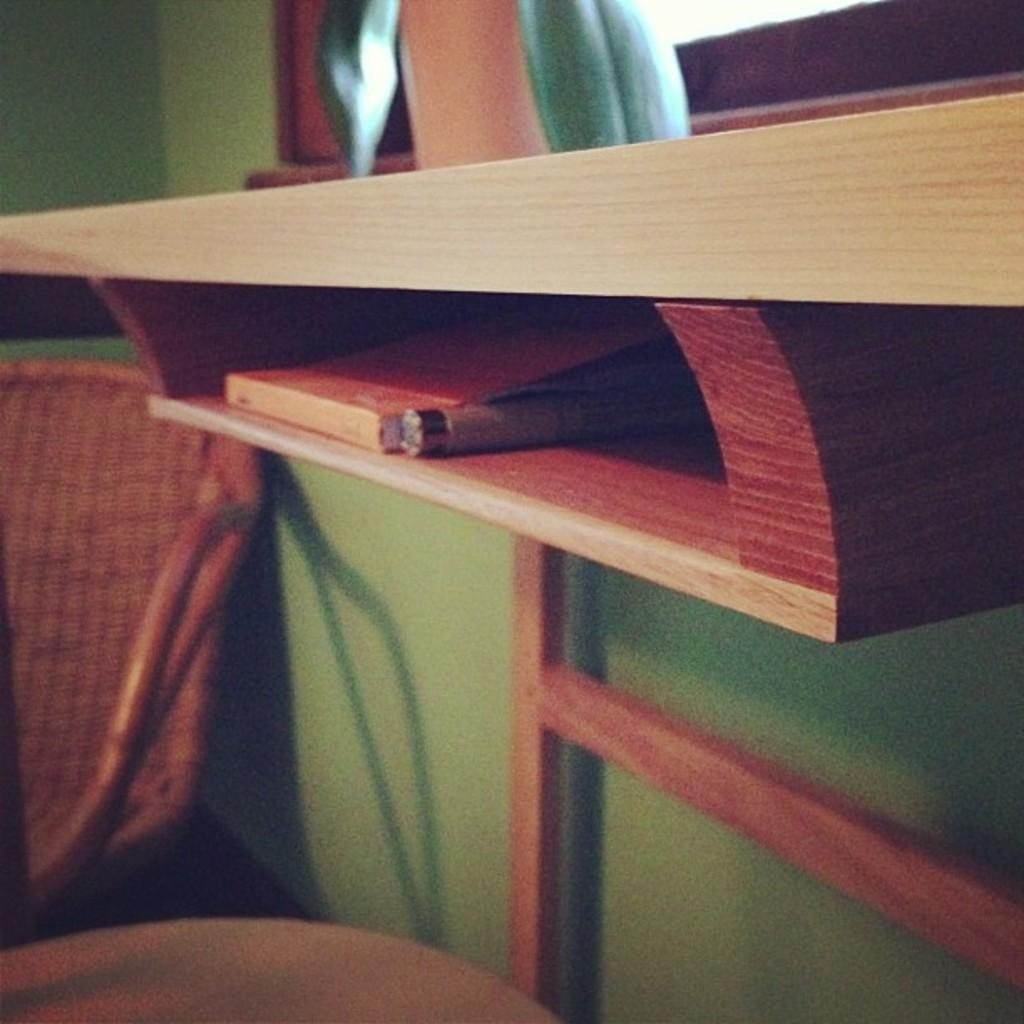What type of furniture is present in the image? There is a chair and a table in the image. What can be found on the shelves in the image? The image only shows that there are shelves, but it does not specify what is on them. What is the book used for in the image? The purpose of the book in the image cannot be determined from the provided facts. What is the pen used for in the image? The purpose of the pen in the image cannot be determined from the provided facts. What is the wall's function in the image? The wall serves as a background or boundary in the image. How many unspecified objects are present in the image? The number of unspecified objects in the image cannot be determined from the provided facts. What type of idea is being expressed by the crow on the side of the wall in the image? There is no crow present in the image, so it is not possible to answer this question. 